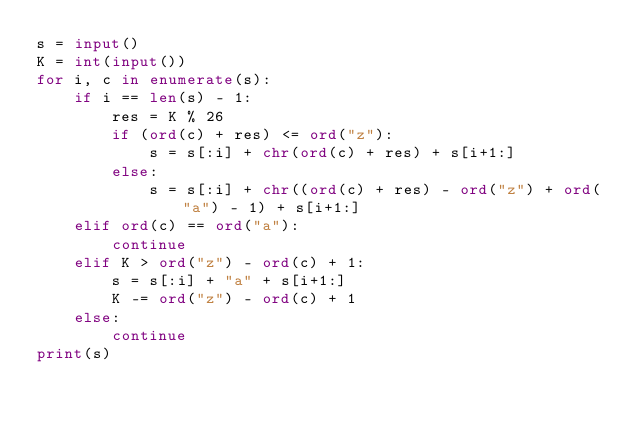<code> <loc_0><loc_0><loc_500><loc_500><_Python_>s = input()
K = int(input())
for i, c in enumerate(s):
    if i == len(s) - 1:
        res = K % 26
        if (ord(c) + res) <= ord("z"):
            s = s[:i] + chr(ord(c) + res) + s[i+1:]
        else:
            s = s[:i] + chr((ord(c) + res) - ord("z") + ord("a") - 1) + s[i+1:]
    elif ord(c) == ord("a"):
        continue
    elif K > ord("z") - ord(c) + 1:
        s = s[:i] + "a" + s[i+1:]
        K -= ord("z") - ord(c) + 1
    else:
        continue
print(s)</code> 